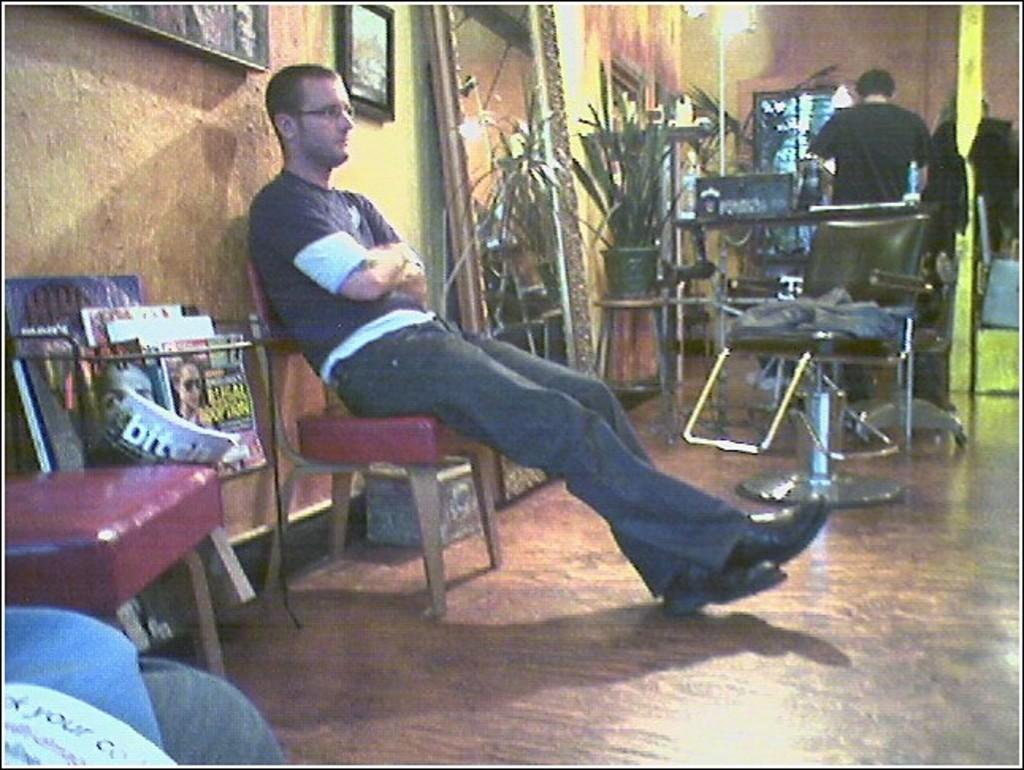How many people are in the room? There are two people in the room, one sitting and one standing. What are the people in the room doing? The fact sheet does not specify what the people are doing, but they are present in the room. Can you describe the contents of the room? The fact sheet mentions that there are many things present in the room, but it does not specify what those things are. What type of copper material can be seen on the wall in the image? There is no mention of copper or a wall in the provided facts, so we cannot answer this question based on the information given. 